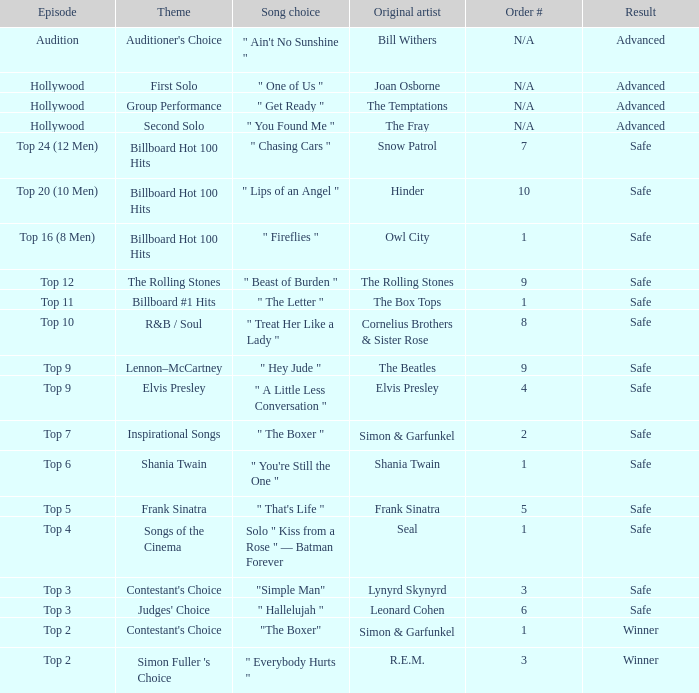Who is the original artist of the song choice " The Letter "? The Box Tops. 